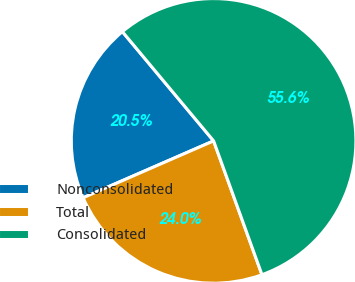Convert chart. <chart><loc_0><loc_0><loc_500><loc_500><pie_chart><fcel>Nonconsolidated<fcel>Total<fcel>Consolidated<nl><fcel>20.47%<fcel>23.98%<fcel>55.56%<nl></chart> 